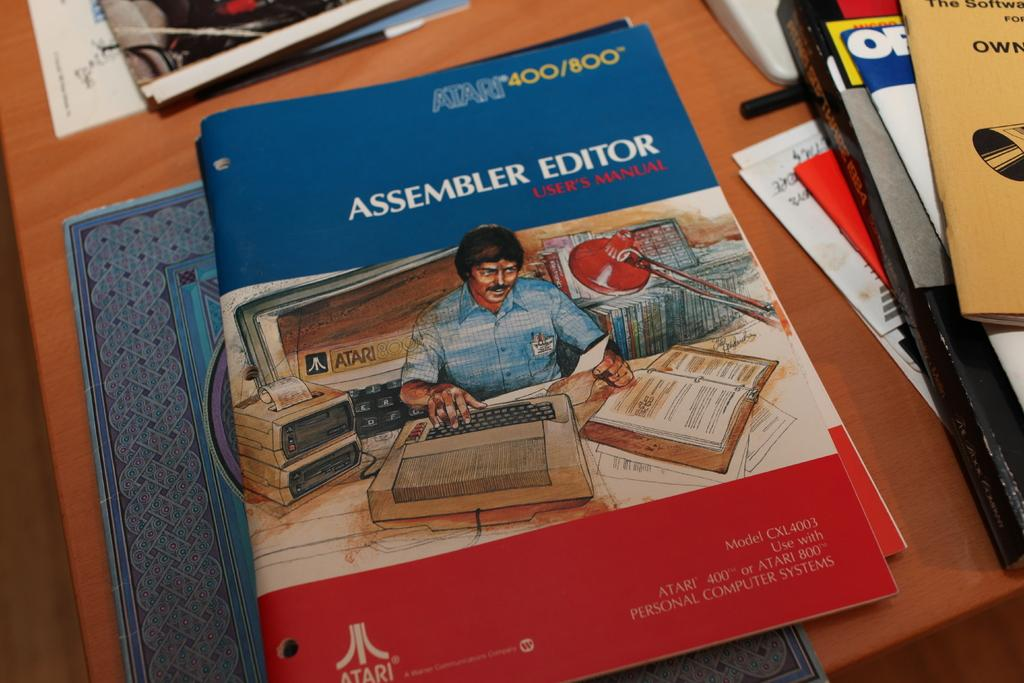<image>
Share a concise interpretation of the image provided. A blue, red and white book setting on top other books with the title assembler editor. 